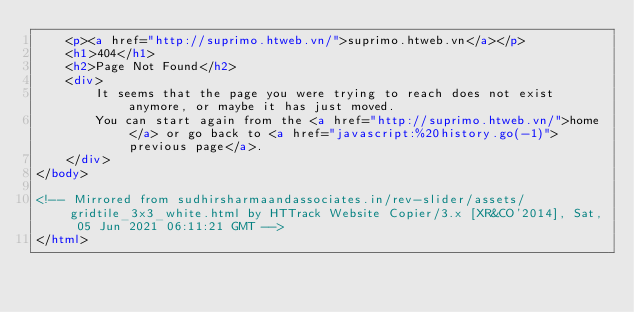Convert code to text. <code><loc_0><loc_0><loc_500><loc_500><_HTML_>    <p><a href="http://suprimo.htweb.vn/">suprimo.htweb.vn</a></p>
    <h1>404</h1>
    <h2>Page Not Found</h2>
    <div>
        It seems that the page you were trying to reach does not exist anymore, or maybe it has just moved.
        You can start again from the <a href="http://suprimo.htweb.vn/">home</a> or go back to <a href="javascript:%20history.go(-1)">previous page</a>.
    </div>
</body>

<!-- Mirrored from sudhirsharmaandassociates.in/rev-slider/assets/gridtile_3x3_white.html by HTTrack Website Copier/3.x [XR&CO'2014], Sat, 05 Jun 2021 06:11:21 GMT -->
</html>
</code> 